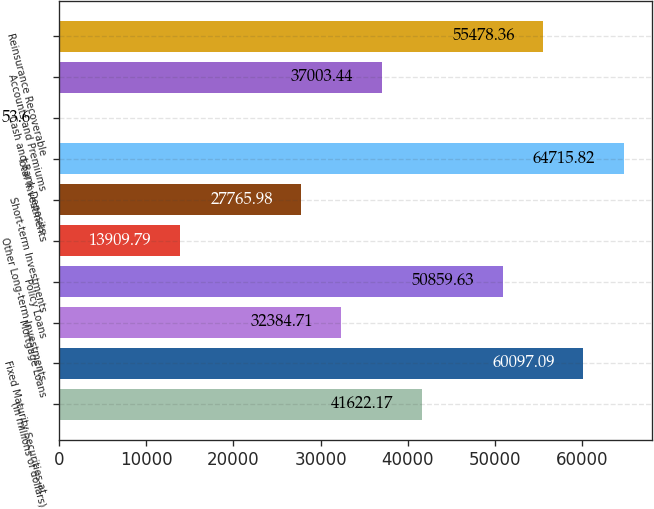<chart> <loc_0><loc_0><loc_500><loc_500><bar_chart><fcel>(in millions of dollars)<fcel>Fixed Maturity Securities-at<fcel>Mortgage Loans<fcel>Policy Loans<fcel>Other Long-term Investments<fcel>Short-term Investments<fcel>Total Investments<fcel>Cash and Bank Deposits<fcel>Accounts and Premiums<fcel>Reinsurance Recoverable<nl><fcel>41622.2<fcel>60097.1<fcel>32384.7<fcel>50859.6<fcel>13909.8<fcel>27766<fcel>64715.8<fcel>53.6<fcel>37003.4<fcel>55478.4<nl></chart> 